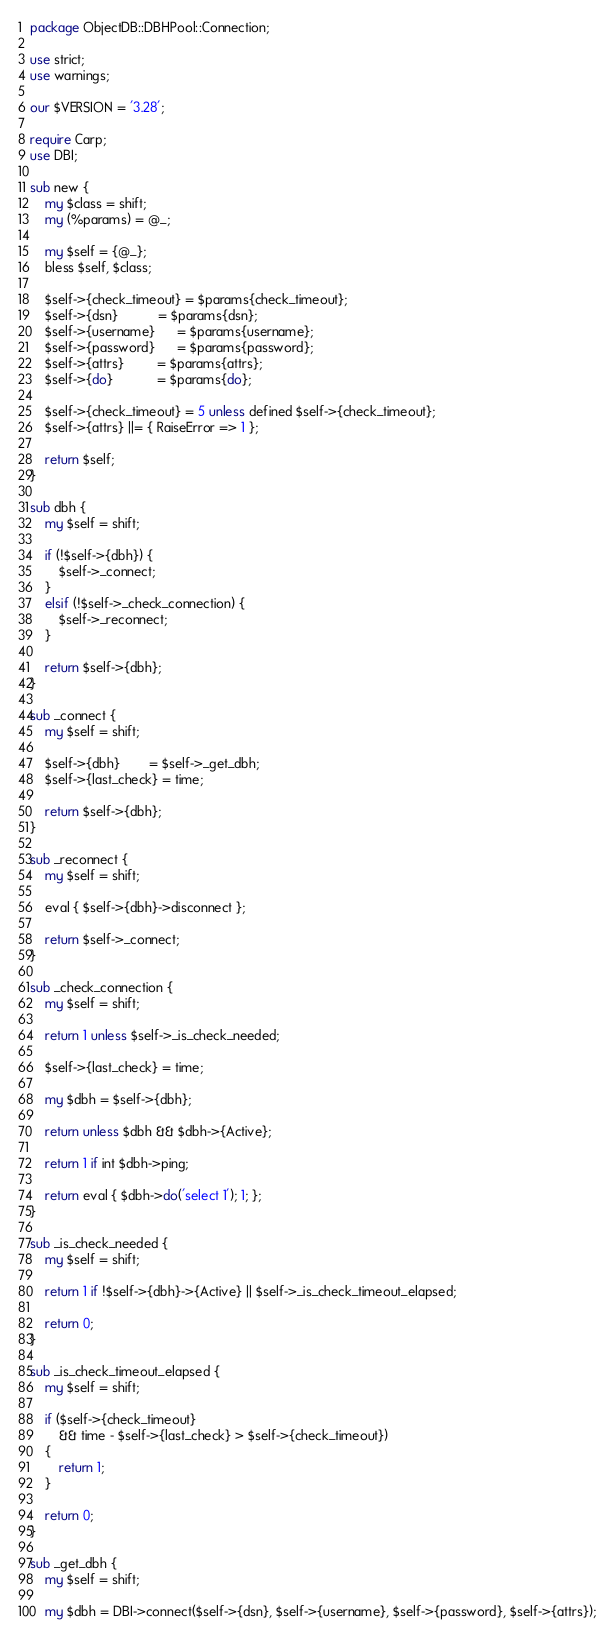Convert code to text. <code><loc_0><loc_0><loc_500><loc_500><_Perl_>package ObjectDB::DBHPool::Connection;

use strict;
use warnings;

our $VERSION = '3.28';

require Carp;
use DBI;

sub new {
    my $class = shift;
    my (%params) = @_;

    my $self = {@_};
    bless $self, $class;

    $self->{check_timeout} = $params{check_timeout};
    $self->{dsn}           = $params{dsn};
    $self->{username}      = $params{username};
    $self->{password}      = $params{password};
    $self->{attrs}         = $params{attrs};
    $self->{do}            = $params{do};

    $self->{check_timeout} = 5 unless defined $self->{check_timeout};
    $self->{attrs} ||= { RaiseError => 1 };

    return $self;
}

sub dbh {
    my $self = shift;

    if (!$self->{dbh}) {
        $self->_connect;
    }
    elsif (!$self->_check_connection) {
        $self->_reconnect;
    }

    return $self->{dbh};
}

sub _connect {
    my $self = shift;

    $self->{dbh}        = $self->_get_dbh;
    $self->{last_check} = time;

    return $self->{dbh};
}

sub _reconnect {
    my $self = shift;

    eval { $self->{dbh}->disconnect };

    return $self->_connect;
}

sub _check_connection {
    my $self = shift;

    return 1 unless $self->_is_check_needed;

    $self->{last_check} = time;

    my $dbh = $self->{dbh};

    return unless $dbh && $dbh->{Active};

    return 1 if int $dbh->ping;

    return eval { $dbh->do('select 1'); 1; };
}

sub _is_check_needed {
    my $self = shift;

    return 1 if !$self->{dbh}->{Active} || $self->_is_check_timeout_elapsed;

    return 0;
}

sub _is_check_timeout_elapsed {
    my $self = shift;

    if ($self->{check_timeout}
        && time - $self->{last_check} > $self->{check_timeout})
    {
        return 1;
    }

    return 0;
}

sub _get_dbh {
    my $self = shift;

    my $dbh = DBI->connect($self->{dsn}, $self->{username}, $self->{password}, $self->{attrs});
</code> 